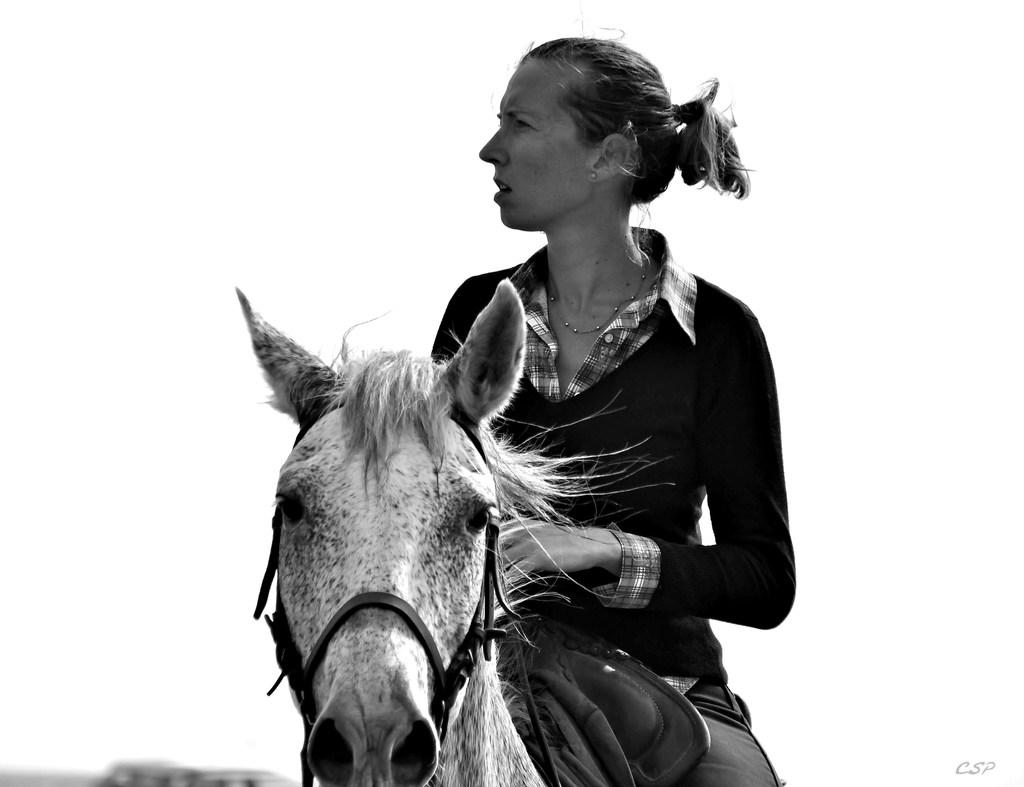Who is the main subject in the image? There is a woman in the image. What is the woman doing in the image? The woman is sitting on a horse. What is the woman looking at in the image? The woman is looking at something. What can be seen in the background of the image? There is sky visible in the background of the image. Reasoning: shirt in the image. How many friends are visible in the image? There are no friends visible in the image; it only features a woman sitting on a horse. What type of linen can be seen draped over the horse in the image? There is no linen present in the image; the woman is sitting on a horse without any visible linen. 